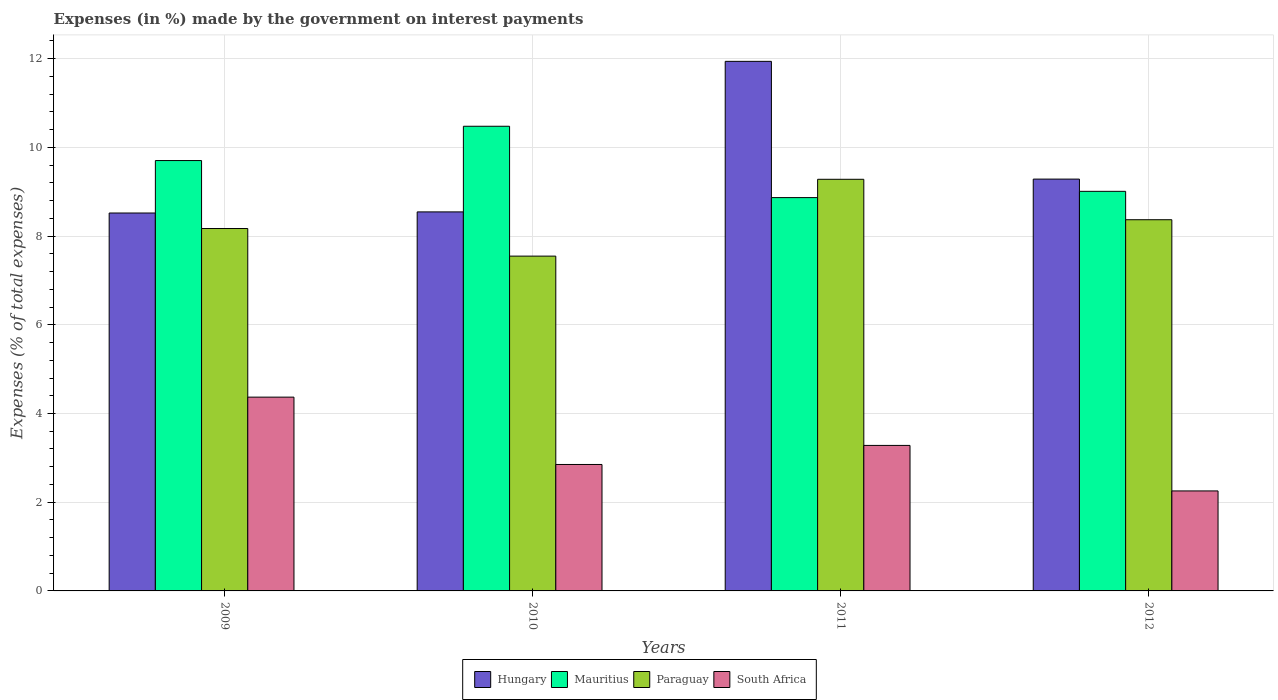How many groups of bars are there?
Offer a very short reply. 4. Are the number of bars per tick equal to the number of legend labels?
Your answer should be compact. Yes. How many bars are there on the 2nd tick from the left?
Keep it short and to the point. 4. How many bars are there on the 2nd tick from the right?
Offer a very short reply. 4. What is the label of the 4th group of bars from the left?
Offer a terse response. 2012. What is the percentage of expenses made by the government on interest payments in Paraguay in 2010?
Give a very brief answer. 7.55. Across all years, what is the maximum percentage of expenses made by the government on interest payments in Mauritius?
Make the answer very short. 10.48. Across all years, what is the minimum percentage of expenses made by the government on interest payments in South Africa?
Keep it short and to the point. 2.25. In which year was the percentage of expenses made by the government on interest payments in Hungary maximum?
Keep it short and to the point. 2011. In which year was the percentage of expenses made by the government on interest payments in Paraguay minimum?
Your answer should be compact. 2010. What is the total percentage of expenses made by the government on interest payments in Mauritius in the graph?
Make the answer very short. 38.05. What is the difference between the percentage of expenses made by the government on interest payments in South Africa in 2010 and that in 2012?
Provide a short and direct response. 0.6. What is the difference between the percentage of expenses made by the government on interest payments in South Africa in 2011 and the percentage of expenses made by the government on interest payments in Paraguay in 2010?
Your answer should be very brief. -4.27. What is the average percentage of expenses made by the government on interest payments in South Africa per year?
Offer a terse response. 3.19. In the year 2011, what is the difference between the percentage of expenses made by the government on interest payments in South Africa and percentage of expenses made by the government on interest payments in Hungary?
Your answer should be compact. -8.66. What is the ratio of the percentage of expenses made by the government on interest payments in Hungary in 2009 to that in 2010?
Your response must be concise. 1. What is the difference between the highest and the second highest percentage of expenses made by the government on interest payments in Hungary?
Your answer should be compact. 2.65. What is the difference between the highest and the lowest percentage of expenses made by the government on interest payments in Paraguay?
Your answer should be very brief. 1.73. Is the sum of the percentage of expenses made by the government on interest payments in Paraguay in 2009 and 2012 greater than the maximum percentage of expenses made by the government on interest payments in Mauritius across all years?
Your answer should be compact. Yes. What does the 3rd bar from the left in 2009 represents?
Your response must be concise. Paraguay. What does the 3rd bar from the right in 2010 represents?
Your answer should be compact. Mauritius. How many bars are there?
Give a very brief answer. 16. How many years are there in the graph?
Offer a terse response. 4. Does the graph contain any zero values?
Give a very brief answer. No. Does the graph contain grids?
Keep it short and to the point. Yes. How are the legend labels stacked?
Provide a succinct answer. Horizontal. What is the title of the graph?
Provide a succinct answer. Expenses (in %) made by the government on interest payments. Does "Mozambique" appear as one of the legend labels in the graph?
Your response must be concise. No. What is the label or title of the X-axis?
Keep it short and to the point. Years. What is the label or title of the Y-axis?
Ensure brevity in your answer.  Expenses (% of total expenses). What is the Expenses (% of total expenses) in Hungary in 2009?
Ensure brevity in your answer.  8.52. What is the Expenses (% of total expenses) of Mauritius in 2009?
Ensure brevity in your answer.  9.7. What is the Expenses (% of total expenses) in Paraguay in 2009?
Your answer should be compact. 8.17. What is the Expenses (% of total expenses) in South Africa in 2009?
Your response must be concise. 4.37. What is the Expenses (% of total expenses) of Hungary in 2010?
Your response must be concise. 8.54. What is the Expenses (% of total expenses) in Mauritius in 2010?
Your answer should be compact. 10.48. What is the Expenses (% of total expenses) of Paraguay in 2010?
Make the answer very short. 7.55. What is the Expenses (% of total expenses) in South Africa in 2010?
Provide a short and direct response. 2.85. What is the Expenses (% of total expenses) of Hungary in 2011?
Your answer should be compact. 11.94. What is the Expenses (% of total expenses) of Mauritius in 2011?
Provide a short and direct response. 8.87. What is the Expenses (% of total expenses) in Paraguay in 2011?
Ensure brevity in your answer.  9.28. What is the Expenses (% of total expenses) of South Africa in 2011?
Give a very brief answer. 3.28. What is the Expenses (% of total expenses) in Hungary in 2012?
Offer a terse response. 9.28. What is the Expenses (% of total expenses) of Mauritius in 2012?
Ensure brevity in your answer.  9.01. What is the Expenses (% of total expenses) in Paraguay in 2012?
Your answer should be compact. 8.37. What is the Expenses (% of total expenses) of South Africa in 2012?
Your response must be concise. 2.25. Across all years, what is the maximum Expenses (% of total expenses) in Hungary?
Ensure brevity in your answer.  11.94. Across all years, what is the maximum Expenses (% of total expenses) in Mauritius?
Your answer should be very brief. 10.48. Across all years, what is the maximum Expenses (% of total expenses) of Paraguay?
Offer a very short reply. 9.28. Across all years, what is the maximum Expenses (% of total expenses) of South Africa?
Give a very brief answer. 4.37. Across all years, what is the minimum Expenses (% of total expenses) of Hungary?
Provide a short and direct response. 8.52. Across all years, what is the minimum Expenses (% of total expenses) in Mauritius?
Your answer should be compact. 8.87. Across all years, what is the minimum Expenses (% of total expenses) of Paraguay?
Your response must be concise. 7.55. Across all years, what is the minimum Expenses (% of total expenses) in South Africa?
Your answer should be compact. 2.25. What is the total Expenses (% of total expenses) in Hungary in the graph?
Provide a succinct answer. 38.29. What is the total Expenses (% of total expenses) of Mauritius in the graph?
Provide a succinct answer. 38.05. What is the total Expenses (% of total expenses) of Paraguay in the graph?
Your answer should be compact. 33.37. What is the total Expenses (% of total expenses) of South Africa in the graph?
Your answer should be very brief. 12.75. What is the difference between the Expenses (% of total expenses) of Hungary in 2009 and that in 2010?
Offer a very short reply. -0.03. What is the difference between the Expenses (% of total expenses) in Mauritius in 2009 and that in 2010?
Make the answer very short. -0.77. What is the difference between the Expenses (% of total expenses) in Paraguay in 2009 and that in 2010?
Give a very brief answer. 0.62. What is the difference between the Expenses (% of total expenses) in South Africa in 2009 and that in 2010?
Ensure brevity in your answer.  1.52. What is the difference between the Expenses (% of total expenses) of Hungary in 2009 and that in 2011?
Offer a very short reply. -3.42. What is the difference between the Expenses (% of total expenses) of Mauritius in 2009 and that in 2011?
Give a very brief answer. 0.83. What is the difference between the Expenses (% of total expenses) in Paraguay in 2009 and that in 2011?
Provide a succinct answer. -1.11. What is the difference between the Expenses (% of total expenses) of South Africa in 2009 and that in 2011?
Your response must be concise. 1.09. What is the difference between the Expenses (% of total expenses) in Hungary in 2009 and that in 2012?
Ensure brevity in your answer.  -0.76. What is the difference between the Expenses (% of total expenses) in Mauritius in 2009 and that in 2012?
Your answer should be very brief. 0.69. What is the difference between the Expenses (% of total expenses) in Paraguay in 2009 and that in 2012?
Your answer should be compact. -0.2. What is the difference between the Expenses (% of total expenses) of South Africa in 2009 and that in 2012?
Make the answer very short. 2.11. What is the difference between the Expenses (% of total expenses) in Hungary in 2010 and that in 2011?
Keep it short and to the point. -3.39. What is the difference between the Expenses (% of total expenses) in Mauritius in 2010 and that in 2011?
Offer a very short reply. 1.61. What is the difference between the Expenses (% of total expenses) in Paraguay in 2010 and that in 2011?
Keep it short and to the point. -1.73. What is the difference between the Expenses (% of total expenses) of South Africa in 2010 and that in 2011?
Ensure brevity in your answer.  -0.43. What is the difference between the Expenses (% of total expenses) of Hungary in 2010 and that in 2012?
Give a very brief answer. -0.74. What is the difference between the Expenses (% of total expenses) in Mauritius in 2010 and that in 2012?
Provide a succinct answer. 1.47. What is the difference between the Expenses (% of total expenses) of Paraguay in 2010 and that in 2012?
Offer a very short reply. -0.82. What is the difference between the Expenses (% of total expenses) of South Africa in 2010 and that in 2012?
Keep it short and to the point. 0.6. What is the difference between the Expenses (% of total expenses) in Hungary in 2011 and that in 2012?
Provide a succinct answer. 2.65. What is the difference between the Expenses (% of total expenses) of Mauritius in 2011 and that in 2012?
Ensure brevity in your answer.  -0.14. What is the difference between the Expenses (% of total expenses) of Paraguay in 2011 and that in 2012?
Make the answer very short. 0.91. What is the difference between the Expenses (% of total expenses) in South Africa in 2011 and that in 2012?
Ensure brevity in your answer.  1.03. What is the difference between the Expenses (% of total expenses) of Hungary in 2009 and the Expenses (% of total expenses) of Mauritius in 2010?
Your answer should be compact. -1.96. What is the difference between the Expenses (% of total expenses) in Hungary in 2009 and the Expenses (% of total expenses) in Paraguay in 2010?
Give a very brief answer. 0.97. What is the difference between the Expenses (% of total expenses) in Hungary in 2009 and the Expenses (% of total expenses) in South Africa in 2010?
Your answer should be compact. 5.67. What is the difference between the Expenses (% of total expenses) in Mauritius in 2009 and the Expenses (% of total expenses) in Paraguay in 2010?
Your response must be concise. 2.15. What is the difference between the Expenses (% of total expenses) of Mauritius in 2009 and the Expenses (% of total expenses) of South Africa in 2010?
Make the answer very short. 6.85. What is the difference between the Expenses (% of total expenses) in Paraguay in 2009 and the Expenses (% of total expenses) in South Africa in 2010?
Your answer should be very brief. 5.32. What is the difference between the Expenses (% of total expenses) in Hungary in 2009 and the Expenses (% of total expenses) in Mauritius in 2011?
Provide a short and direct response. -0.35. What is the difference between the Expenses (% of total expenses) of Hungary in 2009 and the Expenses (% of total expenses) of Paraguay in 2011?
Provide a succinct answer. -0.76. What is the difference between the Expenses (% of total expenses) of Hungary in 2009 and the Expenses (% of total expenses) of South Africa in 2011?
Your answer should be very brief. 5.24. What is the difference between the Expenses (% of total expenses) in Mauritius in 2009 and the Expenses (% of total expenses) in Paraguay in 2011?
Offer a terse response. 0.42. What is the difference between the Expenses (% of total expenses) in Mauritius in 2009 and the Expenses (% of total expenses) in South Africa in 2011?
Keep it short and to the point. 6.42. What is the difference between the Expenses (% of total expenses) of Paraguay in 2009 and the Expenses (% of total expenses) of South Africa in 2011?
Offer a very short reply. 4.89. What is the difference between the Expenses (% of total expenses) in Hungary in 2009 and the Expenses (% of total expenses) in Mauritius in 2012?
Provide a short and direct response. -0.49. What is the difference between the Expenses (% of total expenses) of Hungary in 2009 and the Expenses (% of total expenses) of Paraguay in 2012?
Provide a short and direct response. 0.15. What is the difference between the Expenses (% of total expenses) of Hungary in 2009 and the Expenses (% of total expenses) of South Africa in 2012?
Give a very brief answer. 6.27. What is the difference between the Expenses (% of total expenses) of Mauritius in 2009 and the Expenses (% of total expenses) of Paraguay in 2012?
Provide a short and direct response. 1.33. What is the difference between the Expenses (% of total expenses) in Mauritius in 2009 and the Expenses (% of total expenses) in South Africa in 2012?
Give a very brief answer. 7.45. What is the difference between the Expenses (% of total expenses) in Paraguay in 2009 and the Expenses (% of total expenses) in South Africa in 2012?
Offer a very short reply. 5.92. What is the difference between the Expenses (% of total expenses) of Hungary in 2010 and the Expenses (% of total expenses) of Mauritius in 2011?
Offer a very short reply. -0.32. What is the difference between the Expenses (% of total expenses) in Hungary in 2010 and the Expenses (% of total expenses) in Paraguay in 2011?
Your answer should be very brief. -0.73. What is the difference between the Expenses (% of total expenses) in Hungary in 2010 and the Expenses (% of total expenses) in South Africa in 2011?
Ensure brevity in your answer.  5.26. What is the difference between the Expenses (% of total expenses) in Mauritius in 2010 and the Expenses (% of total expenses) in Paraguay in 2011?
Give a very brief answer. 1.2. What is the difference between the Expenses (% of total expenses) in Mauritius in 2010 and the Expenses (% of total expenses) in South Africa in 2011?
Your response must be concise. 7.2. What is the difference between the Expenses (% of total expenses) in Paraguay in 2010 and the Expenses (% of total expenses) in South Africa in 2011?
Offer a very short reply. 4.27. What is the difference between the Expenses (% of total expenses) in Hungary in 2010 and the Expenses (% of total expenses) in Mauritius in 2012?
Keep it short and to the point. -0.46. What is the difference between the Expenses (% of total expenses) of Hungary in 2010 and the Expenses (% of total expenses) of Paraguay in 2012?
Keep it short and to the point. 0.18. What is the difference between the Expenses (% of total expenses) of Hungary in 2010 and the Expenses (% of total expenses) of South Africa in 2012?
Your response must be concise. 6.29. What is the difference between the Expenses (% of total expenses) in Mauritius in 2010 and the Expenses (% of total expenses) in Paraguay in 2012?
Your response must be concise. 2.11. What is the difference between the Expenses (% of total expenses) of Mauritius in 2010 and the Expenses (% of total expenses) of South Africa in 2012?
Offer a very short reply. 8.22. What is the difference between the Expenses (% of total expenses) of Paraguay in 2010 and the Expenses (% of total expenses) of South Africa in 2012?
Offer a terse response. 5.29. What is the difference between the Expenses (% of total expenses) of Hungary in 2011 and the Expenses (% of total expenses) of Mauritius in 2012?
Keep it short and to the point. 2.93. What is the difference between the Expenses (% of total expenses) of Hungary in 2011 and the Expenses (% of total expenses) of Paraguay in 2012?
Provide a short and direct response. 3.57. What is the difference between the Expenses (% of total expenses) in Hungary in 2011 and the Expenses (% of total expenses) in South Africa in 2012?
Provide a short and direct response. 9.68. What is the difference between the Expenses (% of total expenses) in Mauritius in 2011 and the Expenses (% of total expenses) in Paraguay in 2012?
Give a very brief answer. 0.5. What is the difference between the Expenses (% of total expenses) in Mauritius in 2011 and the Expenses (% of total expenses) in South Africa in 2012?
Offer a very short reply. 6.61. What is the difference between the Expenses (% of total expenses) in Paraguay in 2011 and the Expenses (% of total expenses) in South Africa in 2012?
Your response must be concise. 7.03. What is the average Expenses (% of total expenses) in Hungary per year?
Your answer should be very brief. 9.57. What is the average Expenses (% of total expenses) of Mauritius per year?
Your answer should be compact. 9.51. What is the average Expenses (% of total expenses) in Paraguay per year?
Your answer should be very brief. 8.34. What is the average Expenses (% of total expenses) of South Africa per year?
Give a very brief answer. 3.19. In the year 2009, what is the difference between the Expenses (% of total expenses) in Hungary and Expenses (% of total expenses) in Mauritius?
Ensure brevity in your answer.  -1.18. In the year 2009, what is the difference between the Expenses (% of total expenses) in Hungary and Expenses (% of total expenses) in Paraguay?
Your answer should be compact. 0.35. In the year 2009, what is the difference between the Expenses (% of total expenses) of Hungary and Expenses (% of total expenses) of South Africa?
Provide a short and direct response. 4.15. In the year 2009, what is the difference between the Expenses (% of total expenses) of Mauritius and Expenses (% of total expenses) of Paraguay?
Make the answer very short. 1.53. In the year 2009, what is the difference between the Expenses (% of total expenses) of Mauritius and Expenses (% of total expenses) of South Africa?
Make the answer very short. 5.33. In the year 2009, what is the difference between the Expenses (% of total expenses) in Paraguay and Expenses (% of total expenses) in South Africa?
Make the answer very short. 3.8. In the year 2010, what is the difference between the Expenses (% of total expenses) in Hungary and Expenses (% of total expenses) in Mauritius?
Ensure brevity in your answer.  -1.93. In the year 2010, what is the difference between the Expenses (% of total expenses) of Hungary and Expenses (% of total expenses) of Paraguay?
Your response must be concise. 1. In the year 2010, what is the difference between the Expenses (% of total expenses) in Hungary and Expenses (% of total expenses) in South Africa?
Provide a succinct answer. 5.69. In the year 2010, what is the difference between the Expenses (% of total expenses) in Mauritius and Expenses (% of total expenses) in Paraguay?
Your answer should be very brief. 2.93. In the year 2010, what is the difference between the Expenses (% of total expenses) in Mauritius and Expenses (% of total expenses) in South Africa?
Make the answer very short. 7.62. In the year 2010, what is the difference between the Expenses (% of total expenses) of Paraguay and Expenses (% of total expenses) of South Africa?
Offer a terse response. 4.7. In the year 2011, what is the difference between the Expenses (% of total expenses) in Hungary and Expenses (% of total expenses) in Mauritius?
Give a very brief answer. 3.07. In the year 2011, what is the difference between the Expenses (% of total expenses) of Hungary and Expenses (% of total expenses) of Paraguay?
Offer a very short reply. 2.66. In the year 2011, what is the difference between the Expenses (% of total expenses) in Hungary and Expenses (% of total expenses) in South Africa?
Keep it short and to the point. 8.66. In the year 2011, what is the difference between the Expenses (% of total expenses) of Mauritius and Expenses (% of total expenses) of Paraguay?
Make the answer very short. -0.41. In the year 2011, what is the difference between the Expenses (% of total expenses) of Mauritius and Expenses (% of total expenses) of South Africa?
Give a very brief answer. 5.59. In the year 2011, what is the difference between the Expenses (% of total expenses) in Paraguay and Expenses (% of total expenses) in South Africa?
Your answer should be compact. 6. In the year 2012, what is the difference between the Expenses (% of total expenses) in Hungary and Expenses (% of total expenses) in Mauritius?
Provide a succinct answer. 0.28. In the year 2012, what is the difference between the Expenses (% of total expenses) in Hungary and Expenses (% of total expenses) in Paraguay?
Ensure brevity in your answer.  0.92. In the year 2012, what is the difference between the Expenses (% of total expenses) of Hungary and Expenses (% of total expenses) of South Africa?
Offer a terse response. 7.03. In the year 2012, what is the difference between the Expenses (% of total expenses) of Mauritius and Expenses (% of total expenses) of Paraguay?
Offer a terse response. 0.64. In the year 2012, what is the difference between the Expenses (% of total expenses) in Mauritius and Expenses (% of total expenses) in South Africa?
Your answer should be very brief. 6.75. In the year 2012, what is the difference between the Expenses (% of total expenses) in Paraguay and Expenses (% of total expenses) in South Africa?
Give a very brief answer. 6.11. What is the ratio of the Expenses (% of total expenses) in Hungary in 2009 to that in 2010?
Provide a succinct answer. 1. What is the ratio of the Expenses (% of total expenses) of Mauritius in 2009 to that in 2010?
Your answer should be compact. 0.93. What is the ratio of the Expenses (% of total expenses) of Paraguay in 2009 to that in 2010?
Ensure brevity in your answer.  1.08. What is the ratio of the Expenses (% of total expenses) of South Africa in 2009 to that in 2010?
Provide a short and direct response. 1.53. What is the ratio of the Expenses (% of total expenses) of Hungary in 2009 to that in 2011?
Keep it short and to the point. 0.71. What is the ratio of the Expenses (% of total expenses) of Mauritius in 2009 to that in 2011?
Give a very brief answer. 1.09. What is the ratio of the Expenses (% of total expenses) in Paraguay in 2009 to that in 2011?
Keep it short and to the point. 0.88. What is the ratio of the Expenses (% of total expenses) of South Africa in 2009 to that in 2011?
Give a very brief answer. 1.33. What is the ratio of the Expenses (% of total expenses) of Hungary in 2009 to that in 2012?
Ensure brevity in your answer.  0.92. What is the ratio of the Expenses (% of total expenses) in Mauritius in 2009 to that in 2012?
Your answer should be very brief. 1.08. What is the ratio of the Expenses (% of total expenses) of Paraguay in 2009 to that in 2012?
Provide a short and direct response. 0.98. What is the ratio of the Expenses (% of total expenses) in South Africa in 2009 to that in 2012?
Your answer should be very brief. 1.94. What is the ratio of the Expenses (% of total expenses) of Hungary in 2010 to that in 2011?
Your answer should be very brief. 0.72. What is the ratio of the Expenses (% of total expenses) of Mauritius in 2010 to that in 2011?
Ensure brevity in your answer.  1.18. What is the ratio of the Expenses (% of total expenses) of Paraguay in 2010 to that in 2011?
Your answer should be very brief. 0.81. What is the ratio of the Expenses (% of total expenses) in South Africa in 2010 to that in 2011?
Offer a terse response. 0.87. What is the ratio of the Expenses (% of total expenses) of Hungary in 2010 to that in 2012?
Keep it short and to the point. 0.92. What is the ratio of the Expenses (% of total expenses) in Mauritius in 2010 to that in 2012?
Keep it short and to the point. 1.16. What is the ratio of the Expenses (% of total expenses) in Paraguay in 2010 to that in 2012?
Your answer should be very brief. 0.9. What is the ratio of the Expenses (% of total expenses) in South Africa in 2010 to that in 2012?
Offer a very short reply. 1.26. What is the ratio of the Expenses (% of total expenses) in Hungary in 2011 to that in 2012?
Provide a succinct answer. 1.29. What is the ratio of the Expenses (% of total expenses) of Mauritius in 2011 to that in 2012?
Your answer should be compact. 0.98. What is the ratio of the Expenses (% of total expenses) in Paraguay in 2011 to that in 2012?
Provide a succinct answer. 1.11. What is the ratio of the Expenses (% of total expenses) in South Africa in 2011 to that in 2012?
Keep it short and to the point. 1.46. What is the difference between the highest and the second highest Expenses (% of total expenses) in Hungary?
Your answer should be compact. 2.65. What is the difference between the highest and the second highest Expenses (% of total expenses) in Mauritius?
Offer a terse response. 0.77. What is the difference between the highest and the second highest Expenses (% of total expenses) of Paraguay?
Make the answer very short. 0.91. What is the difference between the highest and the second highest Expenses (% of total expenses) in South Africa?
Ensure brevity in your answer.  1.09. What is the difference between the highest and the lowest Expenses (% of total expenses) in Hungary?
Provide a short and direct response. 3.42. What is the difference between the highest and the lowest Expenses (% of total expenses) in Mauritius?
Your answer should be compact. 1.61. What is the difference between the highest and the lowest Expenses (% of total expenses) in Paraguay?
Offer a terse response. 1.73. What is the difference between the highest and the lowest Expenses (% of total expenses) in South Africa?
Provide a succinct answer. 2.11. 